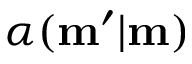<formula> <loc_0><loc_0><loc_500><loc_500>\alpha ( m ^ { \prime } | m )</formula> 